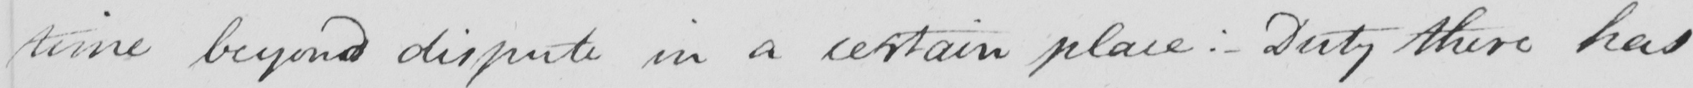Please transcribe the handwritten text in this image. time beyond dispute in a certain place : - Duty there has 